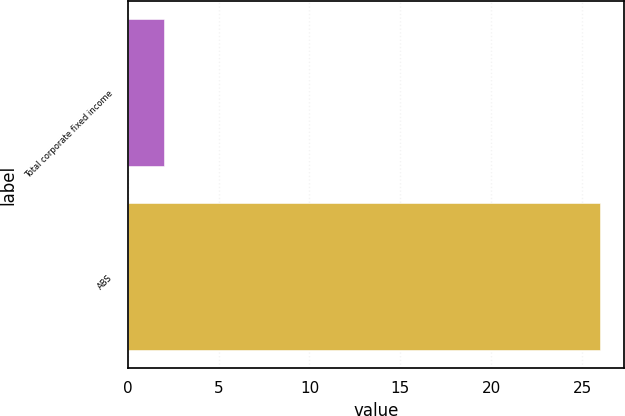<chart> <loc_0><loc_0><loc_500><loc_500><bar_chart><fcel>Total corporate fixed income<fcel>ABS<nl><fcel>2<fcel>26<nl></chart> 